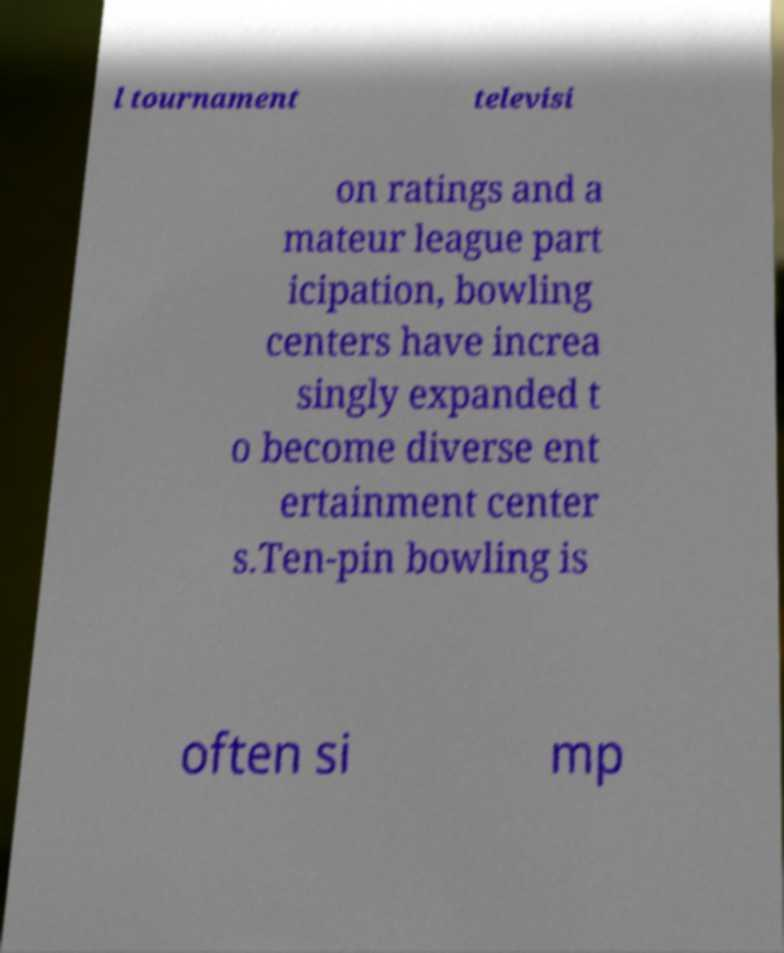For documentation purposes, I need the text within this image transcribed. Could you provide that? l tournament televisi on ratings and a mateur league part icipation, bowling centers have increa singly expanded t o become diverse ent ertainment center s.Ten-pin bowling is often si mp 